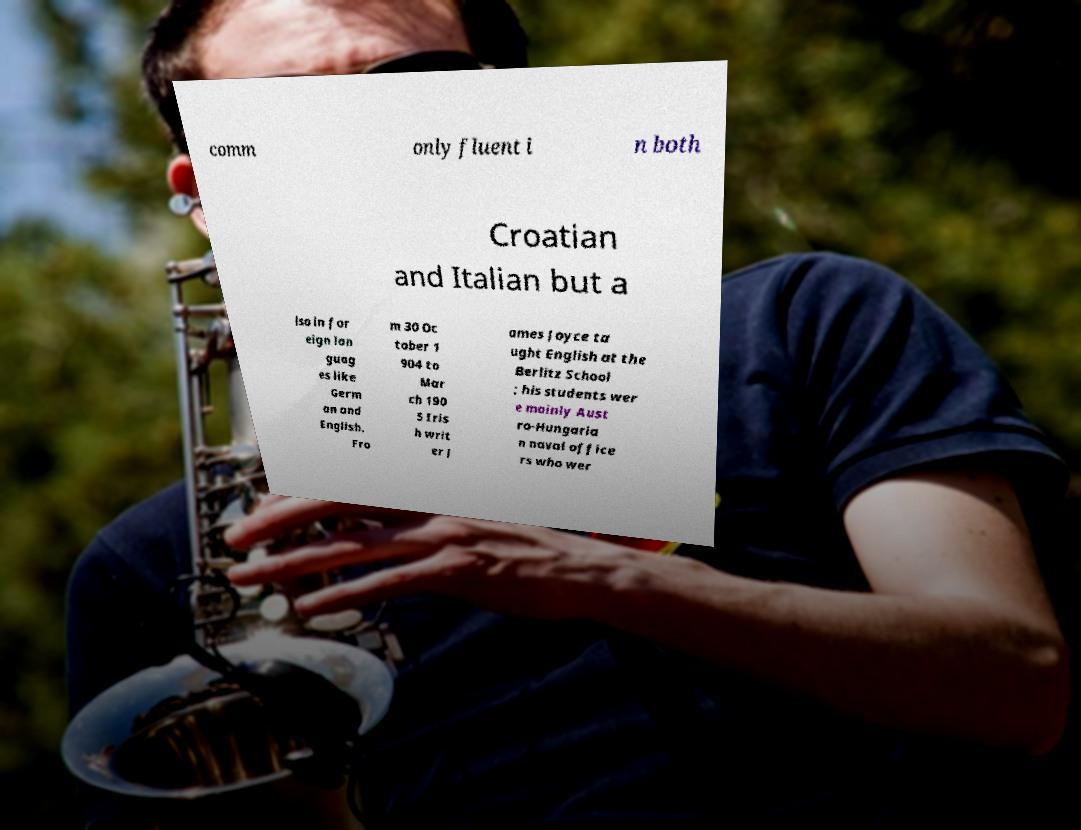Could you extract and type out the text from this image? comm only fluent i n both Croatian and Italian but a lso in for eign lan guag es like Germ an and English. Fro m 30 Oc tober 1 904 to Mar ch 190 5 Iris h writ er J ames Joyce ta ught English at the Berlitz School ; his students wer e mainly Aust ro-Hungaria n naval office rs who wer 